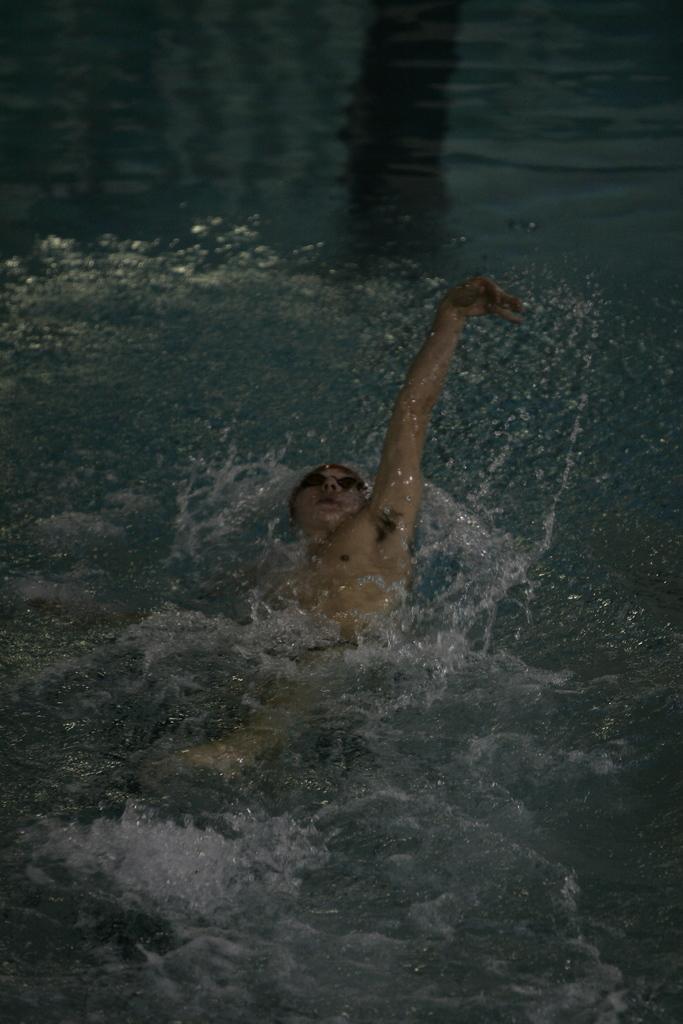Can you describe this image briefly? In this image, we can see a person is swimming in the water. 